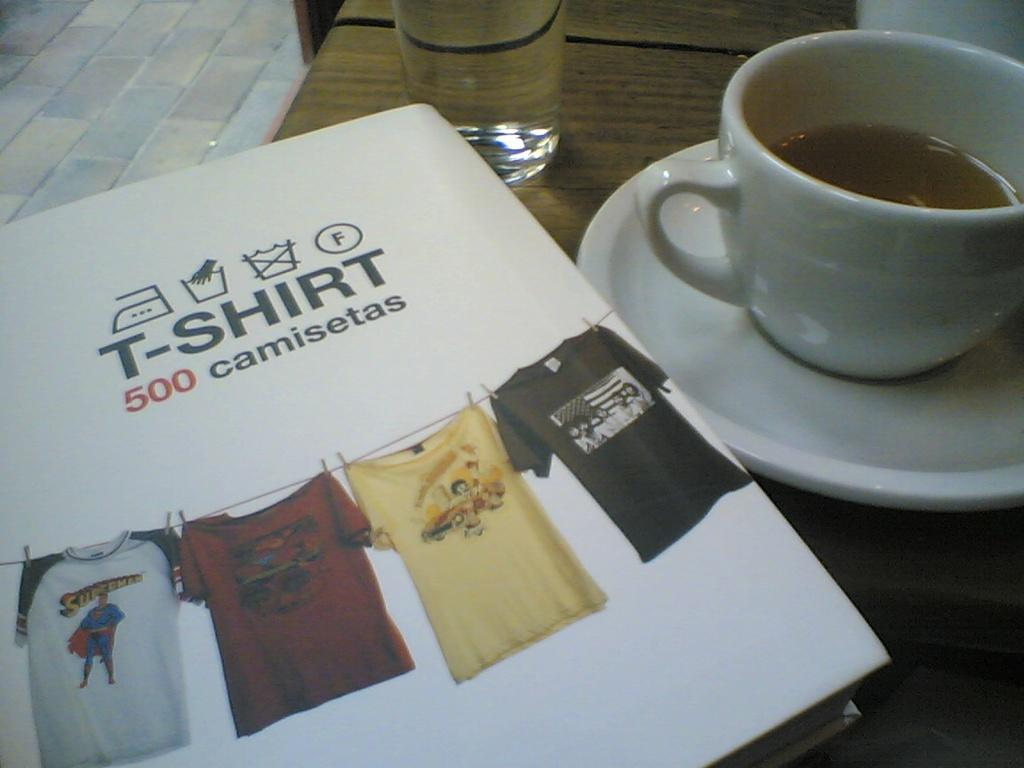<image>
Present a compact description of the photo's key features. Coffee and a book called T-shirt 500 camisetas. 